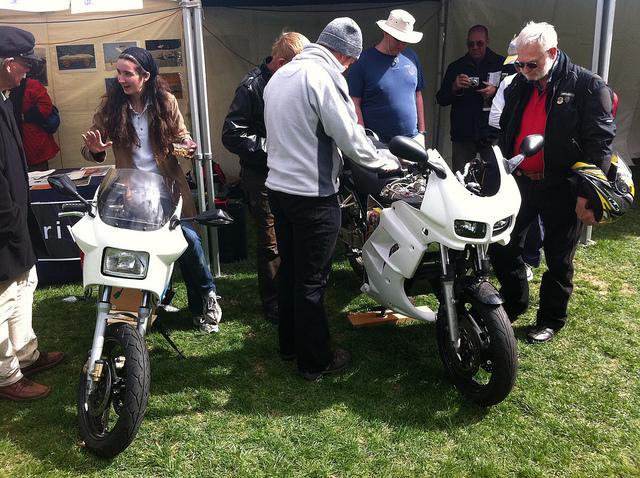Are all the people in this photo men?
Keep it brief. No. What does the man in the blue t-shirt have on his head?
Quick response, please. Hat. Where are the bikes?
Concise answer only. On grass. 